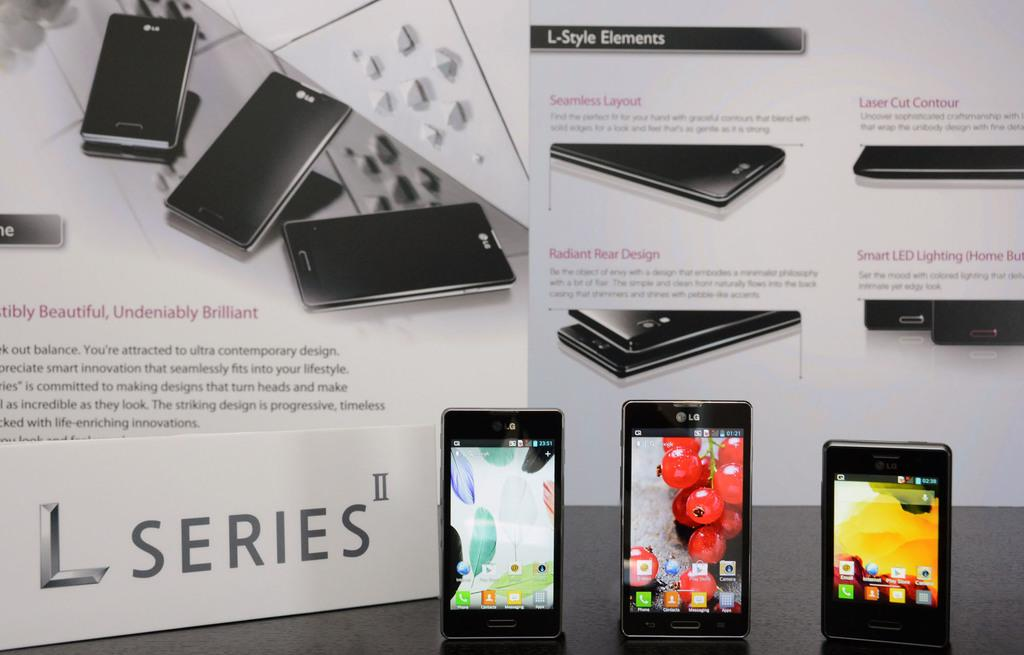<image>
Present a compact description of the photo's key features. A number of L Series II phones by LG. 